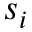Convert formula to latex. <formula><loc_0><loc_0><loc_500><loc_500>s _ { i }</formula> 